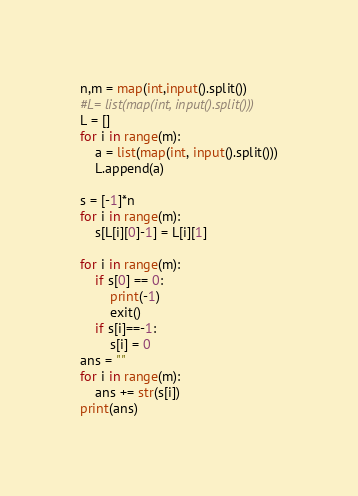<code> <loc_0><loc_0><loc_500><loc_500><_Python_>n,m = map(int,input().split())
#L= list(map(int, input().split()))
L = []
for i in range(m):
    a = list(map(int, input().split()))
    L.append(a)

s = [-1]*n
for i in range(m):
    s[L[i][0]-1] = L[i][1]

for i in range(m):
    if s[0] == 0:
        print(-1)
        exit()
    if s[i]==-1:
        s[i] = 0
ans = ""
for i in range(m):
    ans += str(s[i])
print(ans)</code> 